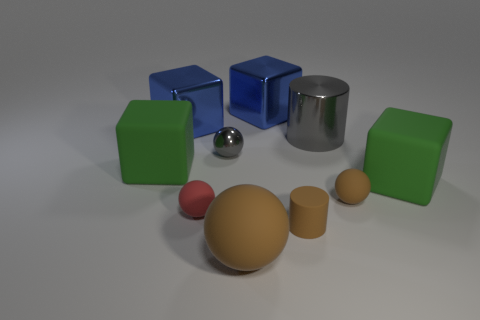Subtract all blue balls. How many green cubes are left? 2 Subtract all red balls. How many balls are left? 3 Subtract all red balls. How many balls are left? 3 Subtract all green spheres. Subtract all purple cubes. How many spheres are left? 4 Subtract all balls. How many objects are left? 6 Subtract 0 purple cylinders. How many objects are left? 10 Subtract all brown cylinders. Subtract all cylinders. How many objects are left? 7 Add 3 brown matte balls. How many brown matte balls are left? 5 Add 3 tiny purple objects. How many tiny purple objects exist? 3 